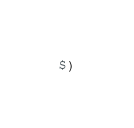<code> <loc_0><loc_0><loc_500><loc_500><_ObjectiveC_>$)
</code> 